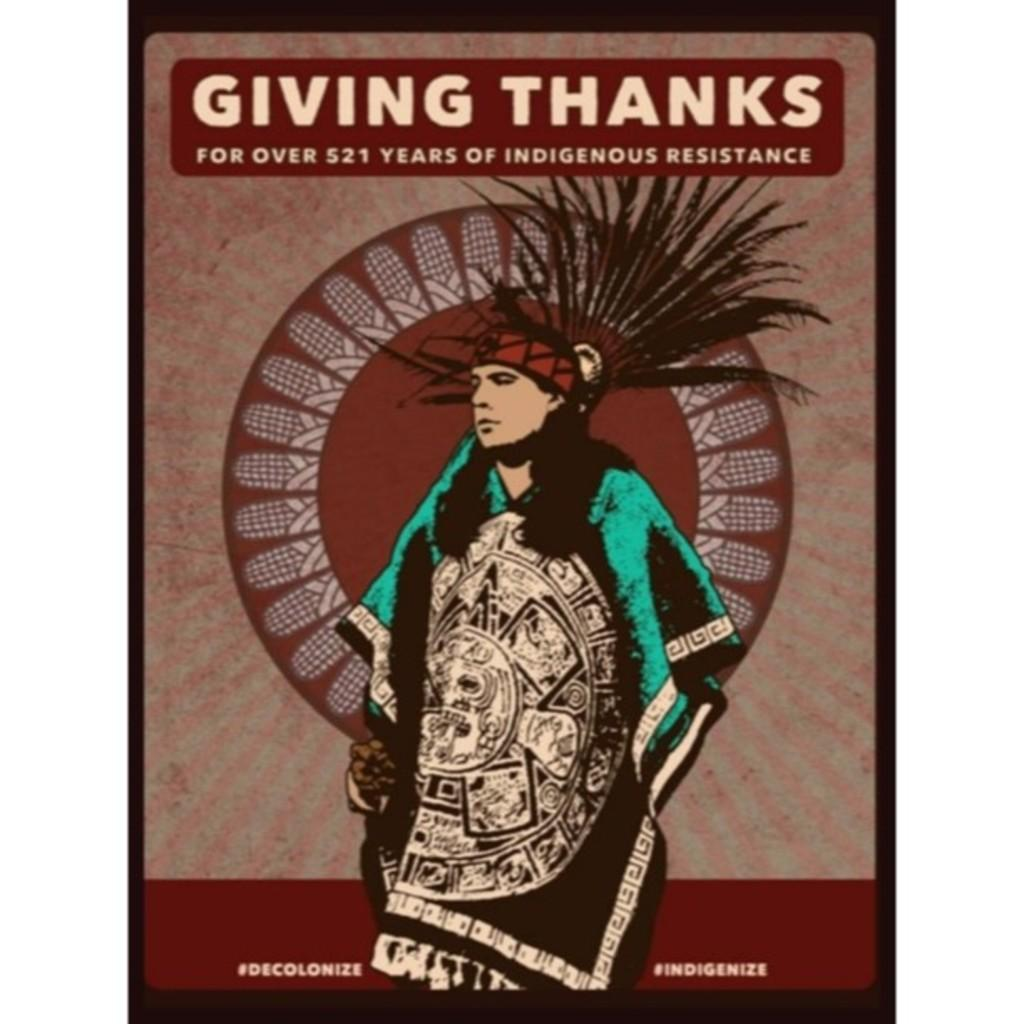What is the main subject of the poster in the image? The main subject of the poster in the image is a tribal man. Where is the tribal man positioned on the poster? The tribal man is standing in the middle of the poster. What additional information is provided on the poster about the tribal man? There is text about the tribal man on the poster. What type of pin is the tribal man wearing on his shirt in the image? There is no pin visible on the tribal man's shirt in the image. What kind of protest is the tribal man participating in, as depicted in the image? The image does not show the tribal man participating in a protest; it only features a poster with an image of him. 